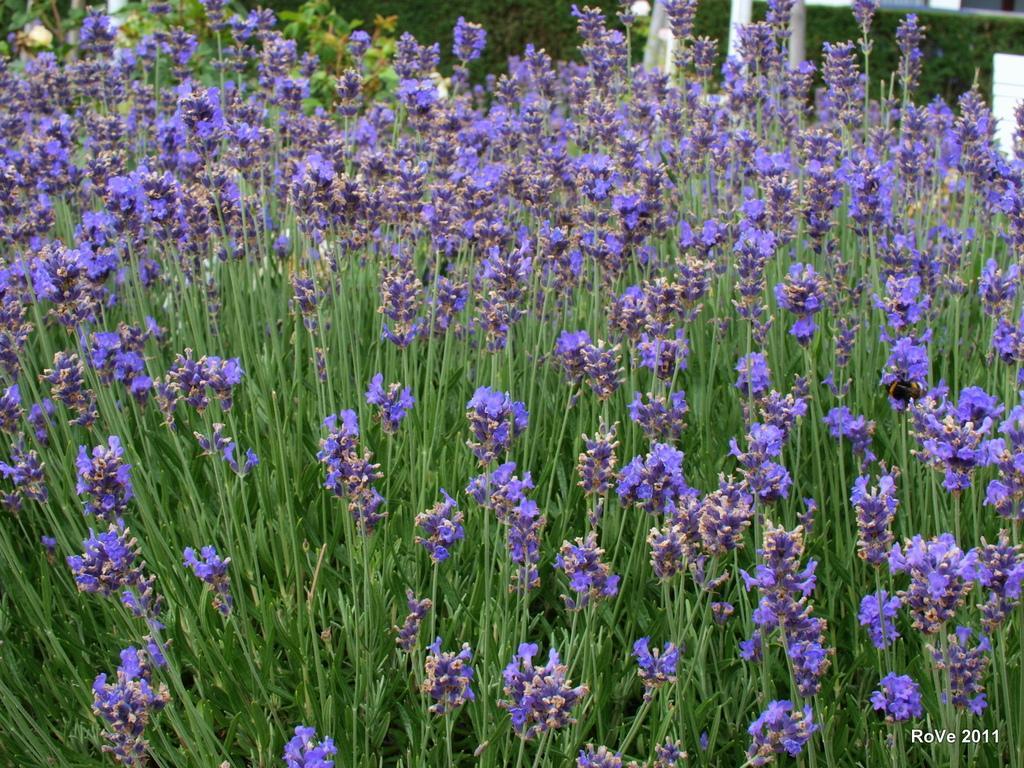Describe this image in one or two sentences. In this image we can see the flower plants. In the bottom right corner we can see the text. 